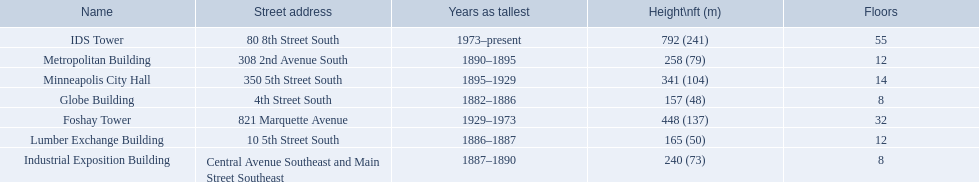How many floors does the globe building have? 8. Which building has 14 floors? Minneapolis City Hall. The lumber exchange building has the same number of floors as which building? Metropolitan Building. 